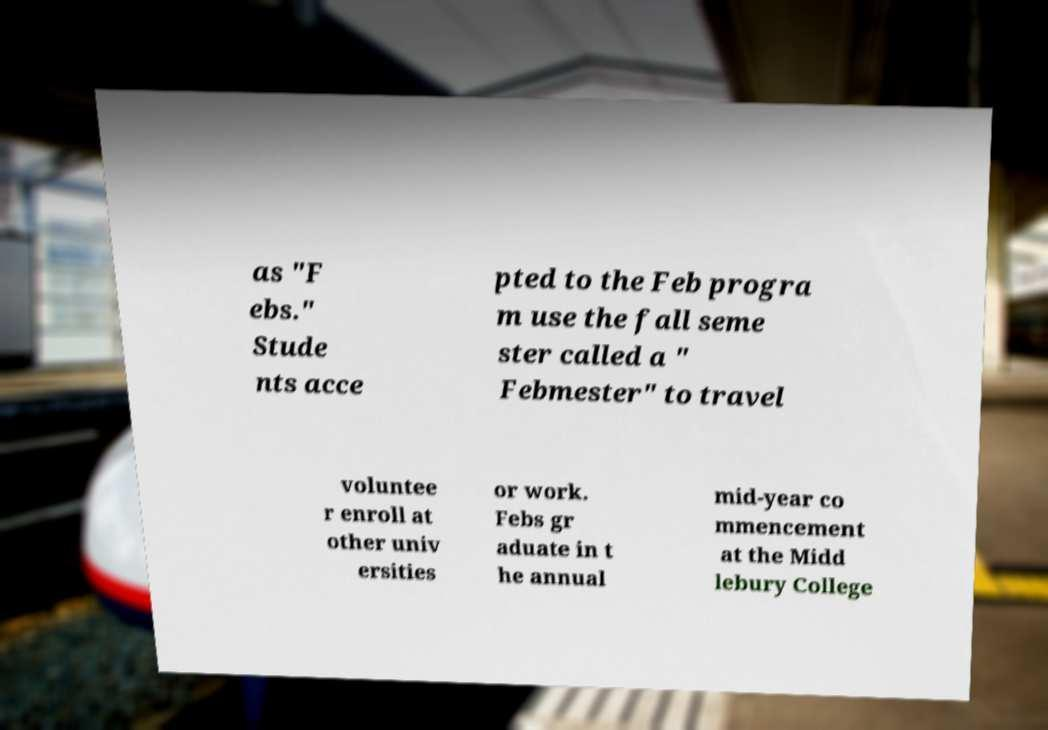I need the written content from this picture converted into text. Can you do that? as "F ebs." Stude nts acce pted to the Feb progra m use the fall seme ster called a " Febmester" to travel voluntee r enroll at other univ ersities or work. Febs gr aduate in t he annual mid-year co mmencement at the Midd lebury College 